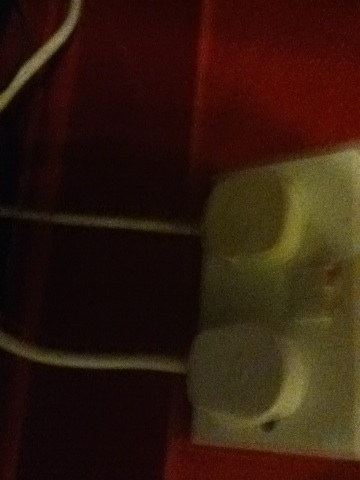Can you describe any colors visible in this blurry image? Although the image is blurry, you can see a contrasting combination of red and white colors. 